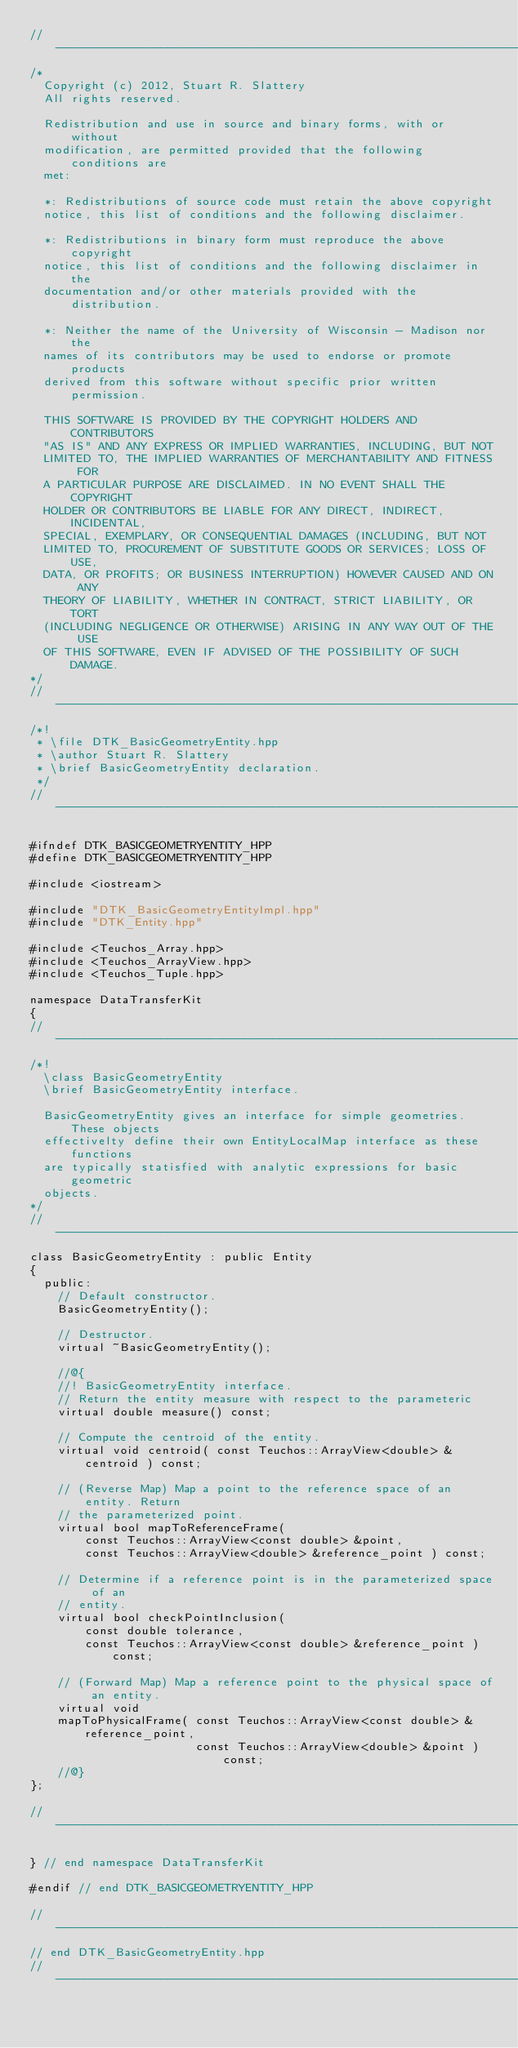Convert code to text. <code><loc_0><loc_0><loc_500><loc_500><_C++_>//---------------------------------------------------------------------------//
/*
  Copyright (c) 2012, Stuart R. Slattery
  All rights reserved.

  Redistribution and use in source and binary forms, with or without
  modification, are permitted provided that the following conditions are
  met:

  *: Redistributions of source code must retain the above copyright
  notice, this list of conditions and the following disclaimer.

  *: Redistributions in binary form must reproduce the above copyright
  notice, this list of conditions and the following disclaimer in the
  documentation and/or other materials provided with the distribution.

  *: Neither the name of the University of Wisconsin - Madison nor the
  names of its contributors may be used to endorse or promote products
  derived from this software without specific prior written permission.

  THIS SOFTWARE IS PROVIDED BY THE COPYRIGHT HOLDERS AND CONTRIBUTORS
  "AS IS" AND ANY EXPRESS OR IMPLIED WARRANTIES, INCLUDING, BUT NOT
  LIMITED TO, THE IMPLIED WARRANTIES OF MERCHANTABILITY AND FITNESS FOR
  A PARTICULAR PURPOSE ARE DISCLAIMED. IN NO EVENT SHALL THE COPYRIGHT
  HOLDER OR CONTRIBUTORS BE LIABLE FOR ANY DIRECT, INDIRECT, INCIDENTAL,
  SPECIAL, EXEMPLARY, OR CONSEQUENTIAL DAMAGES (INCLUDING, BUT NOT
  LIMITED TO, PROCUREMENT OF SUBSTITUTE GOODS OR SERVICES; LOSS OF USE,
  DATA, OR PROFITS; OR BUSINESS INTERRUPTION) HOWEVER CAUSED AND ON ANY
  THEORY OF LIABILITY, WHETHER IN CONTRACT, STRICT LIABILITY, OR TORT
  (INCLUDING NEGLIGENCE OR OTHERWISE) ARISING IN ANY WAY OUT OF THE USE
  OF THIS SOFTWARE, EVEN IF ADVISED OF THE POSSIBILITY OF SUCH DAMAGE.
*/
//---------------------------------------------------------------------------//
/*!
 * \file DTK_BasicGeometryEntity.hpp
 * \author Stuart R. Slattery
 * \brief BasicGeometryEntity declaration.
 */
//---------------------------------------------------------------------------//

#ifndef DTK_BASICGEOMETRYENTITY_HPP
#define DTK_BASICGEOMETRYENTITY_HPP

#include <iostream>

#include "DTK_BasicGeometryEntityImpl.hpp"
#include "DTK_Entity.hpp"

#include <Teuchos_Array.hpp>
#include <Teuchos_ArrayView.hpp>
#include <Teuchos_Tuple.hpp>

namespace DataTransferKit
{
//---------------------------------------------------------------------------//
/*!
  \class BasicGeometryEntity
  \brief BasicGeometryEntity interface.

  BasicGeometryEntity gives an interface for simple geometries. These objects
  effectivelty define their own EntityLocalMap interface as these functions
  are typically statisfied with analytic expressions for basic geometric
  objects.
*/
//---------------------------------------------------------------------------//
class BasicGeometryEntity : public Entity
{
  public:
    // Default constructor.
    BasicGeometryEntity();

    // Destructor.
    virtual ~BasicGeometryEntity();

    //@{
    //! BasicGeometryEntity interface.
    // Return the entity measure with respect to the parameteric
    virtual double measure() const;

    // Compute the centroid of the entity.
    virtual void centroid( const Teuchos::ArrayView<double> &centroid ) const;

    // (Reverse Map) Map a point to the reference space of an entity. Return
    // the parameterized point.
    virtual bool mapToReferenceFrame(
        const Teuchos::ArrayView<const double> &point,
        const Teuchos::ArrayView<double> &reference_point ) const;

    // Determine if a reference point is in the parameterized space of an
    // entity.
    virtual bool checkPointInclusion(
        const double tolerance,
        const Teuchos::ArrayView<const double> &reference_point ) const;

    // (Forward Map) Map a reference point to the physical space of an entity.
    virtual void
    mapToPhysicalFrame( const Teuchos::ArrayView<const double> &reference_point,
                        const Teuchos::ArrayView<double> &point ) const;
    //@}
};

//---------------------------------------------------------------------------//

} // end namespace DataTransferKit

#endif // end DTK_BASICGEOMETRYENTITY_HPP

//---------------------------------------------------------------------------//
// end DTK_BasicGeometryEntity.hpp
//---------------------------------------------------------------------------//
</code> 